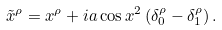Convert formula to latex. <formula><loc_0><loc_0><loc_500><loc_500>\tilde { x } ^ { \rho } = x ^ { \rho } + i a \cos { x ^ { 2 } } \left ( \delta _ { 0 } ^ { \rho } - \delta _ { 1 } ^ { \rho } \right ) .</formula> 